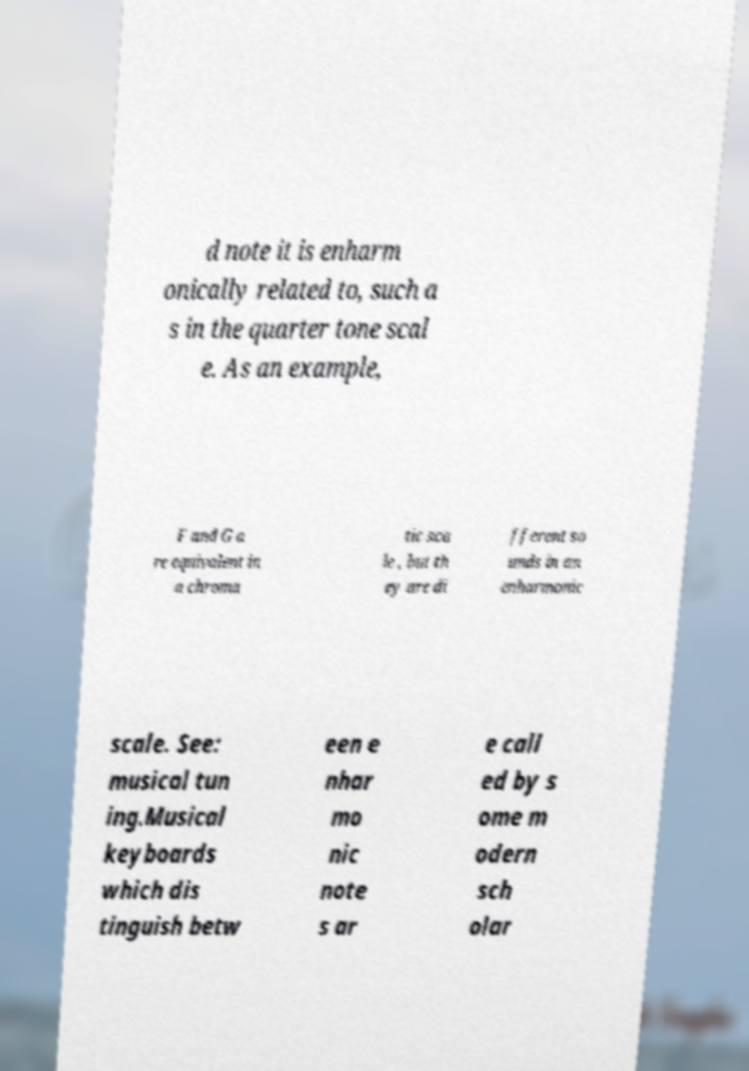Can you read and provide the text displayed in the image?This photo seems to have some interesting text. Can you extract and type it out for me? d note it is enharm onically related to, such a s in the quarter tone scal e. As an example, F and G a re equivalent in a chroma tic sca le , but th ey are di fferent so unds in an enharmonic scale. See: musical tun ing.Musical keyboards which dis tinguish betw een e nhar mo nic note s ar e call ed by s ome m odern sch olar 